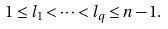Convert formula to latex. <formula><loc_0><loc_0><loc_500><loc_500>1 \leq l _ { 1 } < \cdots < l _ { q } \leq n - 1 .</formula> 